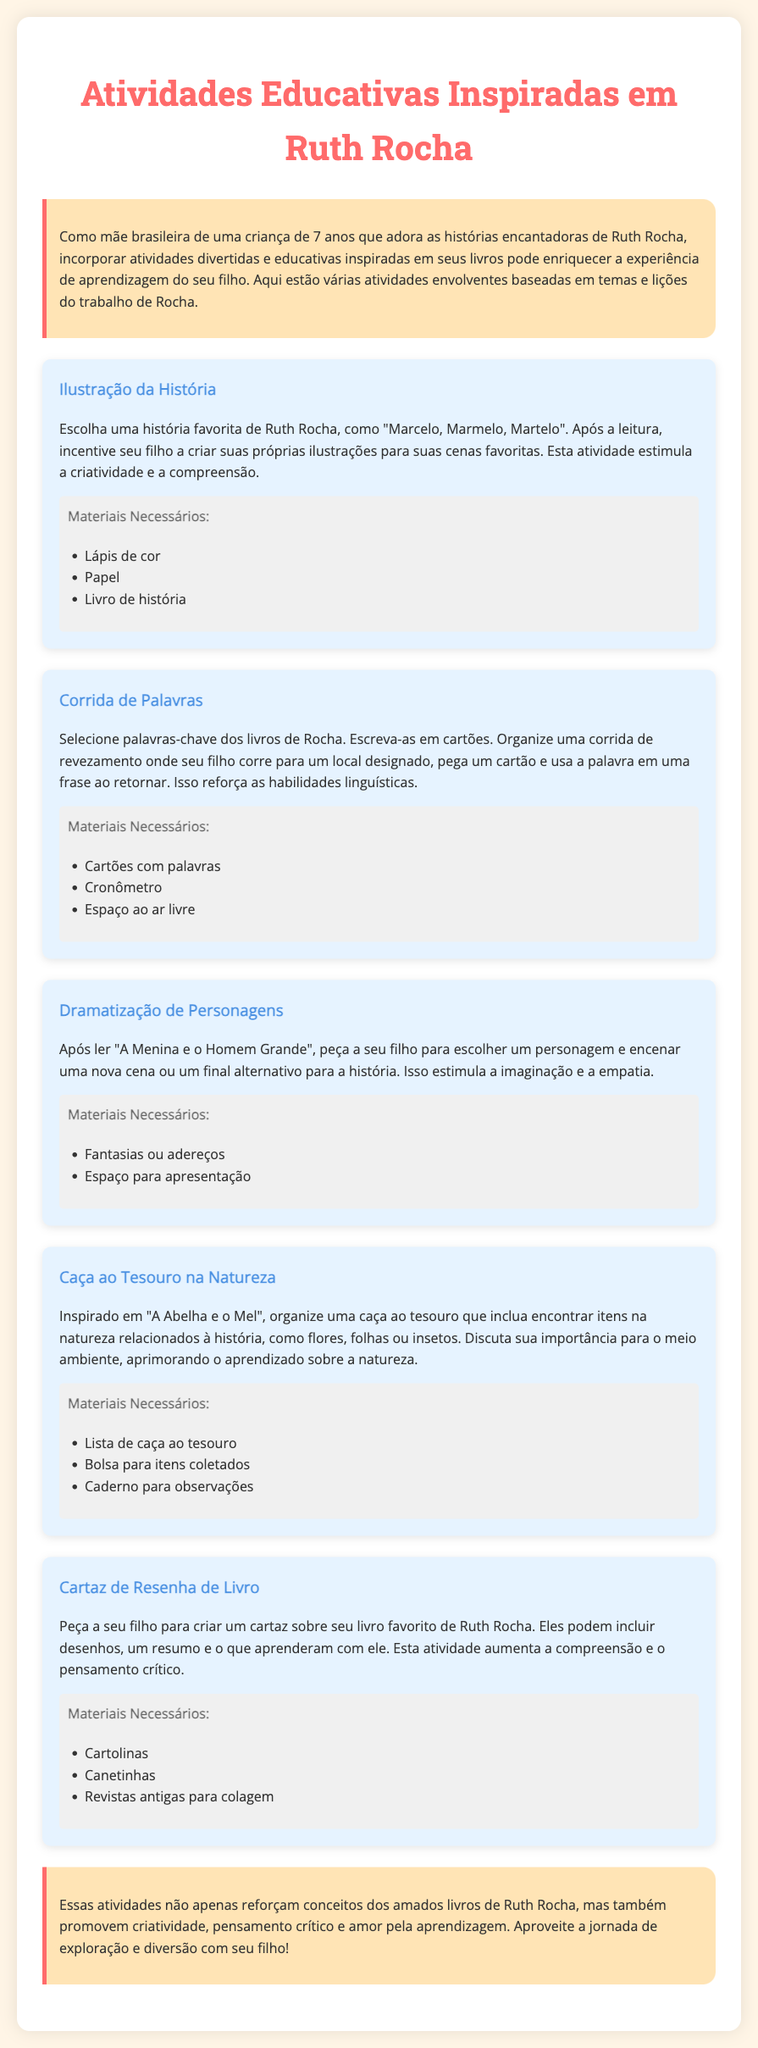Qual é o título do documento? O título é a principal identificação do documento, que costuma estar em destaque.
Answer: Atividades Educativas Inspiradas em Ruth Rocha Quantas atividades educativas são listadas no documento? Contamos o número total de atividades descritas na seção de atividades.
Answer: 5 Qual é o material necessário para a atividade "Ilustração da História"? O material é uma lista de itens que precisam ser usados para realizar a atividade.
Answer: Lápis de cor, Papel, Livro de história Qual livro de Ruth Rocha é mencionado na atividade "Dramatização de Personagens"? A pergunta busca o nome do livro relacionado à atividade que envolve encenação.
Answer: A Menina e o Homem Grande Qual é o foco da atividade "Caça ao Tesouro na Natureza"? O foco é o objetivo principal da atividade educacional, que deverá ser destacado.
Answer: Encontrar itens na natureza relacionados à história Que tipo de habilidade é reforçada na atividade "Corrida de Palavras"? A habilidade que é aprimorada através da atividade é explicitada no texto.
Answer: Habilidades linguísticas Qual é o objetivo final da conclusão do documento? O objetivo final é o que se espera alcançar com todas as atividades apresentadas.
Answer: Promover criatividade, pensamento crítico e amor pela aprendizagem 